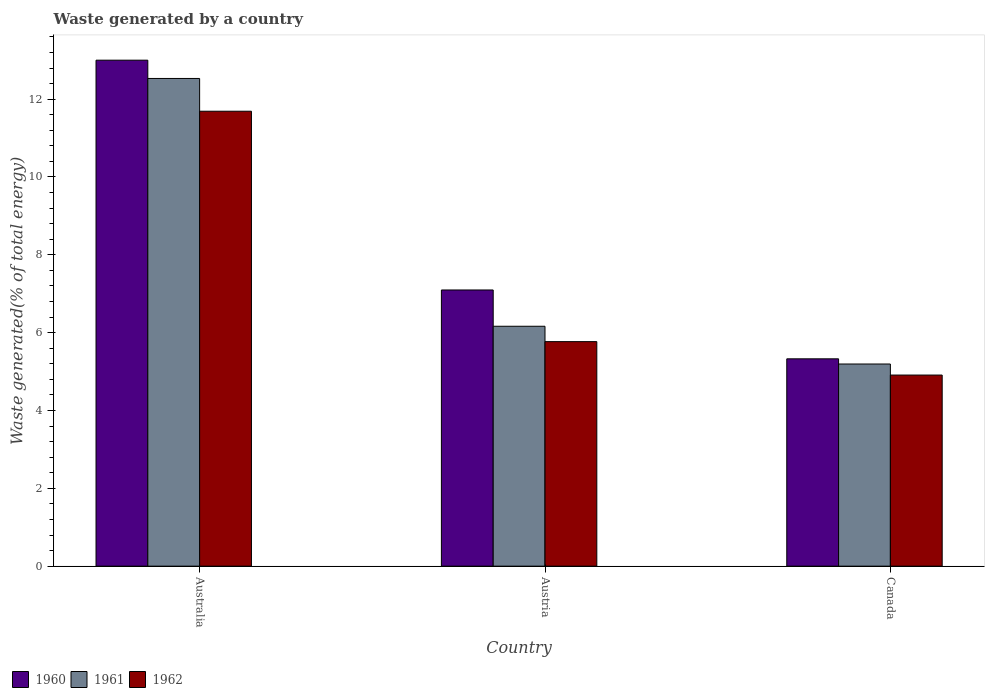Are the number of bars on each tick of the X-axis equal?
Your answer should be very brief. Yes. What is the total waste generated in 1960 in Australia?
Provide a succinct answer. 13. Across all countries, what is the maximum total waste generated in 1961?
Offer a terse response. 12.53. Across all countries, what is the minimum total waste generated in 1961?
Your answer should be very brief. 5.19. In which country was the total waste generated in 1961 maximum?
Offer a very short reply. Australia. What is the total total waste generated in 1962 in the graph?
Give a very brief answer. 22.37. What is the difference between the total waste generated in 1960 in Australia and that in Canada?
Your response must be concise. 7.67. What is the difference between the total waste generated in 1960 in Australia and the total waste generated in 1961 in Canada?
Offer a terse response. 7.81. What is the average total waste generated in 1961 per country?
Provide a succinct answer. 7.96. What is the difference between the total waste generated of/in 1961 and total waste generated of/in 1962 in Austria?
Provide a succinct answer. 0.4. In how many countries, is the total waste generated in 1960 greater than 4 %?
Provide a succinct answer. 3. What is the ratio of the total waste generated in 1961 in Australia to that in Canada?
Offer a terse response. 2.41. Is the difference between the total waste generated in 1961 in Austria and Canada greater than the difference between the total waste generated in 1962 in Austria and Canada?
Give a very brief answer. Yes. What is the difference between the highest and the second highest total waste generated in 1961?
Offer a terse response. 7.34. What is the difference between the highest and the lowest total waste generated in 1960?
Your answer should be compact. 7.67. Is the sum of the total waste generated in 1960 in Australia and Canada greater than the maximum total waste generated in 1962 across all countries?
Provide a short and direct response. Yes. What does the 1st bar from the left in Austria represents?
Your response must be concise. 1960. What does the 3rd bar from the right in Australia represents?
Provide a succinct answer. 1960. Are all the bars in the graph horizontal?
Your response must be concise. No. What is the difference between two consecutive major ticks on the Y-axis?
Provide a short and direct response. 2. Are the values on the major ticks of Y-axis written in scientific E-notation?
Offer a very short reply. No. Does the graph contain any zero values?
Give a very brief answer. No. Does the graph contain grids?
Give a very brief answer. No. Where does the legend appear in the graph?
Offer a terse response. Bottom left. How are the legend labels stacked?
Provide a succinct answer. Horizontal. What is the title of the graph?
Your answer should be compact. Waste generated by a country. Does "1979" appear as one of the legend labels in the graph?
Keep it short and to the point. No. What is the label or title of the X-axis?
Offer a terse response. Country. What is the label or title of the Y-axis?
Your response must be concise. Waste generated(% of total energy). What is the Waste generated(% of total energy) of 1960 in Australia?
Provide a short and direct response. 13. What is the Waste generated(% of total energy) in 1961 in Australia?
Give a very brief answer. 12.53. What is the Waste generated(% of total energy) of 1962 in Australia?
Offer a very short reply. 11.69. What is the Waste generated(% of total energy) in 1960 in Austria?
Provide a succinct answer. 7.1. What is the Waste generated(% of total energy) of 1961 in Austria?
Your response must be concise. 6.16. What is the Waste generated(% of total energy) in 1962 in Austria?
Offer a very short reply. 5.77. What is the Waste generated(% of total energy) in 1960 in Canada?
Your answer should be compact. 5.33. What is the Waste generated(% of total energy) in 1961 in Canada?
Ensure brevity in your answer.  5.19. What is the Waste generated(% of total energy) in 1962 in Canada?
Offer a very short reply. 4.91. Across all countries, what is the maximum Waste generated(% of total energy) in 1960?
Keep it short and to the point. 13. Across all countries, what is the maximum Waste generated(% of total energy) in 1961?
Provide a succinct answer. 12.53. Across all countries, what is the maximum Waste generated(% of total energy) of 1962?
Provide a succinct answer. 11.69. Across all countries, what is the minimum Waste generated(% of total energy) of 1960?
Your response must be concise. 5.33. Across all countries, what is the minimum Waste generated(% of total energy) of 1961?
Make the answer very short. 5.19. Across all countries, what is the minimum Waste generated(% of total energy) of 1962?
Your answer should be compact. 4.91. What is the total Waste generated(% of total energy) in 1960 in the graph?
Provide a succinct answer. 25.43. What is the total Waste generated(% of total energy) of 1961 in the graph?
Provide a short and direct response. 23.89. What is the total Waste generated(% of total energy) of 1962 in the graph?
Give a very brief answer. 22.37. What is the difference between the Waste generated(% of total energy) of 1960 in Australia and that in Austria?
Keep it short and to the point. 5.9. What is the difference between the Waste generated(% of total energy) in 1961 in Australia and that in Austria?
Make the answer very short. 6.37. What is the difference between the Waste generated(% of total energy) in 1962 in Australia and that in Austria?
Your answer should be compact. 5.92. What is the difference between the Waste generated(% of total energy) of 1960 in Australia and that in Canada?
Your answer should be very brief. 7.67. What is the difference between the Waste generated(% of total energy) of 1961 in Australia and that in Canada?
Your answer should be compact. 7.34. What is the difference between the Waste generated(% of total energy) of 1962 in Australia and that in Canada?
Keep it short and to the point. 6.78. What is the difference between the Waste generated(% of total energy) in 1960 in Austria and that in Canada?
Make the answer very short. 1.77. What is the difference between the Waste generated(% of total energy) in 1961 in Austria and that in Canada?
Your response must be concise. 0.97. What is the difference between the Waste generated(% of total energy) in 1962 in Austria and that in Canada?
Your answer should be compact. 0.86. What is the difference between the Waste generated(% of total energy) of 1960 in Australia and the Waste generated(% of total energy) of 1961 in Austria?
Provide a succinct answer. 6.84. What is the difference between the Waste generated(% of total energy) of 1960 in Australia and the Waste generated(% of total energy) of 1962 in Austria?
Ensure brevity in your answer.  7.23. What is the difference between the Waste generated(% of total energy) in 1961 in Australia and the Waste generated(% of total energy) in 1962 in Austria?
Offer a very short reply. 6.76. What is the difference between the Waste generated(% of total energy) of 1960 in Australia and the Waste generated(% of total energy) of 1961 in Canada?
Give a very brief answer. 7.81. What is the difference between the Waste generated(% of total energy) of 1960 in Australia and the Waste generated(% of total energy) of 1962 in Canada?
Provide a short and direct response. 8.09. What is the difference between the Waste generated(% of total energy) of 1961 in Australia and the Waste generated(% of total energy) of 1962 in Canada?
Make the answer very short. 7.62. What is the difference between the Waste generated(% of total energy) of 1960 in Austria and the Waste generated(% of total energy) of 1961 in Canada?
Offer a very short reply. 1.9. What is the difference between the Waste generated(% of total energy) in 1960 in Austria and the Waste generated(% of total energy) in 1962 in Canada?
Make the answer very short. 2.19. What is the difference between the Waste generated(% of total energy) of 1961 in Austria and the Waste generated(% of total energy) of 1962 in Canada?
Your response must be concise. 1.25. What is the average Waste generated(% of total energy) of 1960 per country?
Ensure brevity in your answer.  8.48. What is the average Waste generated(% of total energy) of 1961 per country?
Ensure brevity in your answer.  7.96. What is the average Waste generated(% of total energy) of 1962 per country?
Provide a short and direct response. 7.46. What is the difference between the Waste generated(% of total energy) of 1960 and Waste generated(% of total energy) of 1961 in Australia?
Make the answer very short. 0.47. What is the difference between the Waste generated(% of total energy) in 1960 and Waste generated(% of total energy) in 1962 in Australia?
Your response must be concise. 1.31. What is the difference between the Waste generated(% of total energy) of 1961 and Waste generated(% of total energy) of 1962 in Australia?
Make the answer very short. 0.84. What is the difference between the Waste generated(% of total energy) of 1960 and Waste generated(% of total energy) of 1961 in Austria?
Your response must be concise. 0.93. What is the difference between the Waste generated(% of total energy) of 1960 and Waste generated(% of total energy) of 1962 in Austria?
Offer a terse response. 1.33. What is the difference between the Waste generated(% of total energy) in 1961 and Waste generated(% of total energy) in 1962 in Austria?
Your answer should be very brief. 0.4. What is the difference between the Waste generated(% of total energy) of 1960 and Waste generated(% of total energy) of 1961 in Canada?
Offer a very short reply. 0.13. What is the difference between the Waste generated(% of total energy) of 1960 and Waste generated(% of total energy) of 1962 in Canada?
Ensure brevity in your answer.  0.42. What is the difference between the Waste generated(% of total energy) in 1961 and Waste generated(% of total energy) in 1962 in Canada?
Ensure brevity in your answer.  0.28. What is the ratio of the Waste generated(% of total energy) of 1960 in Australia to that in Austria?
Ensure brevity in your answer.  1.83. What is the ratio of the Waste generated(% of total energy) of 1961 in Australia to that in Austria?
Your response must be concise. 2.03. What is the ratio of the Waste generated(% of total energy) in 1962 in Australia to that in Austria?
Offer a very short reply. 2.03. What is the ratio of the Waste generated(% of total energy) in 1960 in Australia to that in Canada?
Keep it short and to the point. 2.44. What is the ratio of the Waste generated(% of total energy) in 1961 in Australia to that in Canada?
Your answer should be compact. 2.41. What is the ratio of the Waste generated(% of total energy) of 1962 in Australia to that in Canada?
Your answer should be compact. 2.38. What is the ratio of the Waste generated(% of total energy) of 1960 in Austria to that in Canada?
Your answer should be compact. 1.33. What is the ratio of the Waste generated(% of total energy) of 1961 in Austria to that in Canada?
Offer a very short reply. 1.19. What is the ratio of the Waste generated(% of total energy) of 1962 in Austria to that in Canada?
Offer a very short reply. 1.17. What is the difference between the highest and the second highest Waste generated(% of total energy) in 1960?
Keep it short and to the point. 5.9. What is the difference between the highest and the second highest Waste generated(% of total energy) of 1961?
Offer a very short reply. 6.37. What is the difference between the highest and the second highest Waste generated(% of total energy) of 1962?
Ensure brevity in your answer.  5.92. What is the difference between the highest and the lowest Waste generated(% of total energy) in 1960?
Offer a terse response. 7.67. What is the difference between the highest and the lowest Waste generated(% of total energy) of 1961?
Offer a terse response. 7.34. What is the difference between the highest and the lowest Waste generated(% of total energy) in 1962?
Offer a terse response. 6.78. 